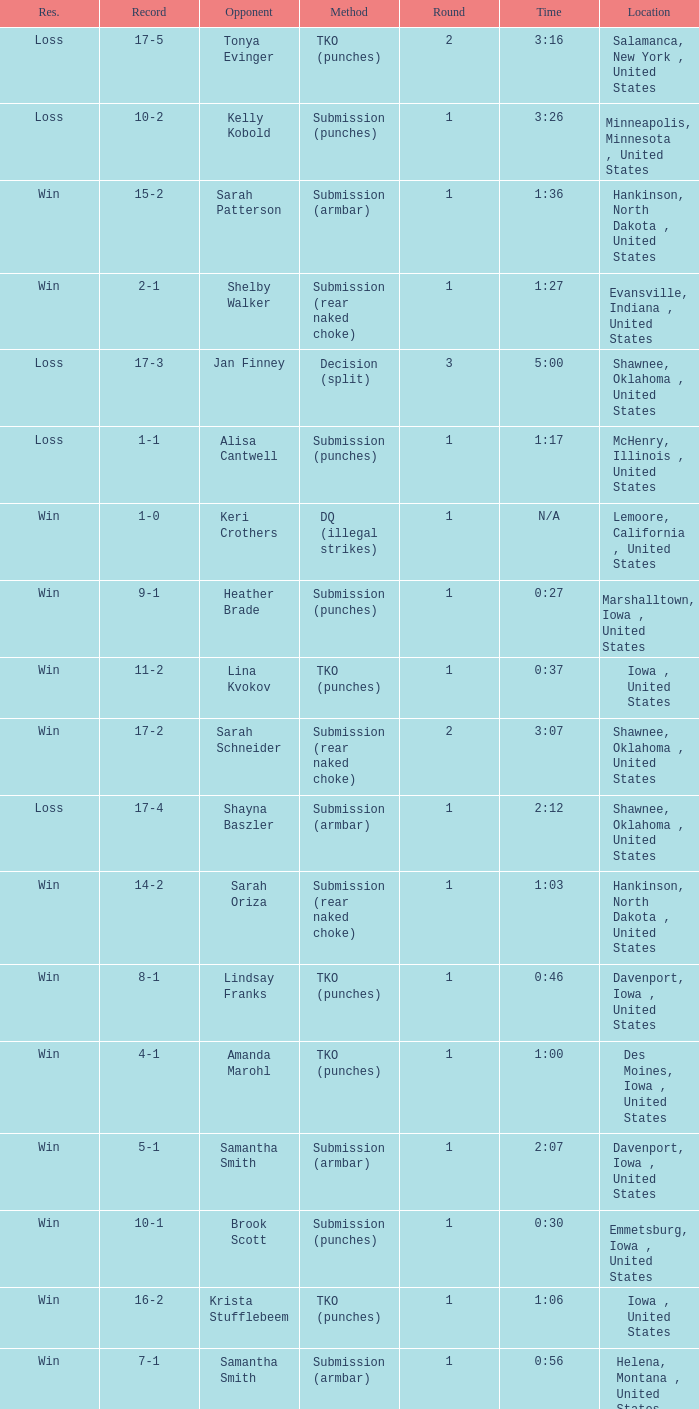What is the highest number of rounds for a 3:16 fight? 2.0. Give me the full table as a dictionary. {'header': ['Res.', 'Record', 'Opponent', 'Method', 'Round', 'Time', 'Location'], 'rows': [['Loss', '17-5', 'Tonya Evinger', 'TKO (punches)', '2', '3:16', 'Salamanca, New York , United States'], ['Loss', '10-2', 'Kelly Kobold', 'Submission (punches)', '1', '3:26', 'Minneapolis, Minnesota , United States'], ['Win', '15-2', 'Sarah Patterson', 'Submission (armbar)', '1', '1:36', 'Hankinson, North Dakota , United States'], ['Win', '2-1', 'Shelby Walker', 'Submission (rear naked choke)', '1', '1:27', 'Evansville, Indiana , United States'], ['Loss', '17-3', 'Jan Finney', 'Decision (split)', '3', '5:00', 'Shawnee, Oklahoma , United States'], ['Loss', '1-1', 'Alisa Cantwell', 'Submission (punches)', '1', '1:17', 'McHenry, Illinois , United States'], ['Win', '1-0', 'Keri Crothers', 'DQ (illegal strikes)', '1', 'N/A', 'Lemoore, California , United States'], ['Win', '9-1', 'Heather Brade', 'Submission (punches)', '1', '0:27', 'Marshalltown, Iowa , United States'], ['Win', '11-2', 'Lina Kvokov', 'TKO (punches)', '1', '0:37', 'Iowa , United States'], ['Win', '17-2', 'Sarah Schneider', 'Submission (rear naked choke)', '2', '3:07', 'Shawnee, Oklahoma , United States'], ['Loss', '17-4', 'Shayna Baszler', 'Submission (armbar)', '1', '2:12', 'Shawnee, Oklahoma , United States'], ['Win', '14-2', 'Sarah Oriza', 'Submission (rear naked choke)', '1', '1:03', 'Hankinson, North Dakota , United States'], ['Win', '8-1', 'Lindsay Franks', 'TKO (punches)', '1', '0:46', 'Davenport, Iowa , United States'], ['Win', '4-1', 'Amanda Marohl', 'TKO (punches)', '1', '1:00', 'Des Moines, Iowa , United States'], ['Win', '5-1', 'Samantha Smith', 'Submission (armbar)', '1', '2:07', 'Davenport, Iowa , United States'], ['Win', '10-1', 'Brook Scott', 'Submission (punches)', '1', '0:30', 'Emmetsburg, Iowa , United States'], ['Win', '16-2', 'Krista Stufflebeem', 'TKO (punches)', '1', '1:06', 'Iowa , United States'], ['Win', '7-1', 'Samantha Smith', 'Submission (armbar)', '1', '0:56', 'Helena, Montana , United States'], ['Win', '6-1', 'Sonya Sargeant', 'TKO (punches)', '1', 'N/A', 'Clive, Iowa , United States'], ['Win', '3-1', 'Cindy Romero', 'Submission (slam)', '1', 'N/A', 'Rochester, Minnesota , United States'], ['Win', '12-2', 'Constance Griffiths', 'TKO (punches)', '1', '1:53', 'Centerville, Iowa , United States'], ['Win', '13-2', 'Jessica Nickerson', 'Submission (punches)', '1', '0:51', 'Iowa , United States']]} 